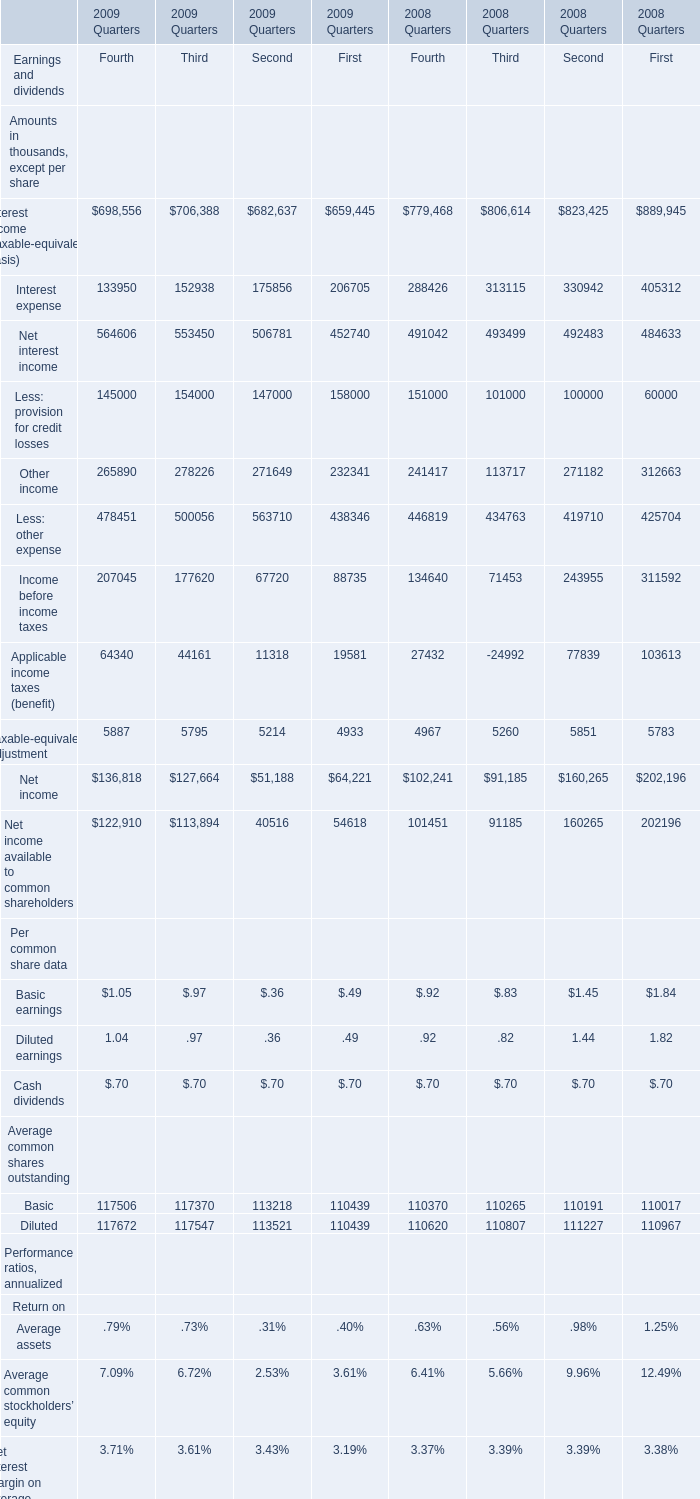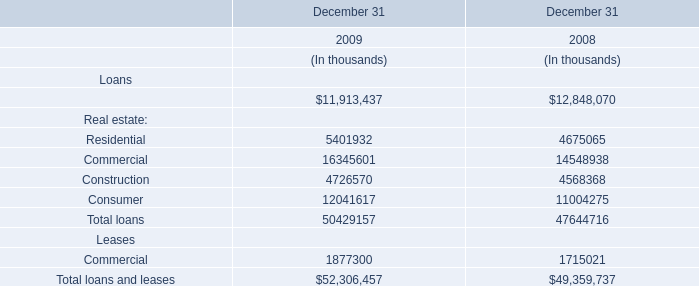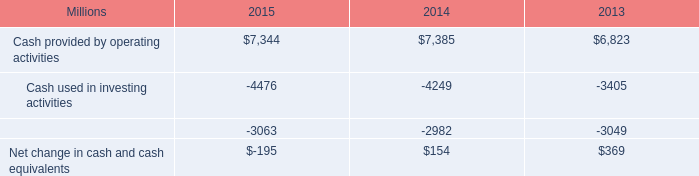What is the total amount of Cash used in investing activities of 2015, and Deposits At end of quarter of 2008 Quarters Second ? 
Computations: (4476.0 + 41926.0)
Answer: 46402.0. 